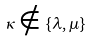<formula> <loc_0><loc_0><loc_500><loc_500>\kappa \notin \{ \lambda , \mu \}</formula> 